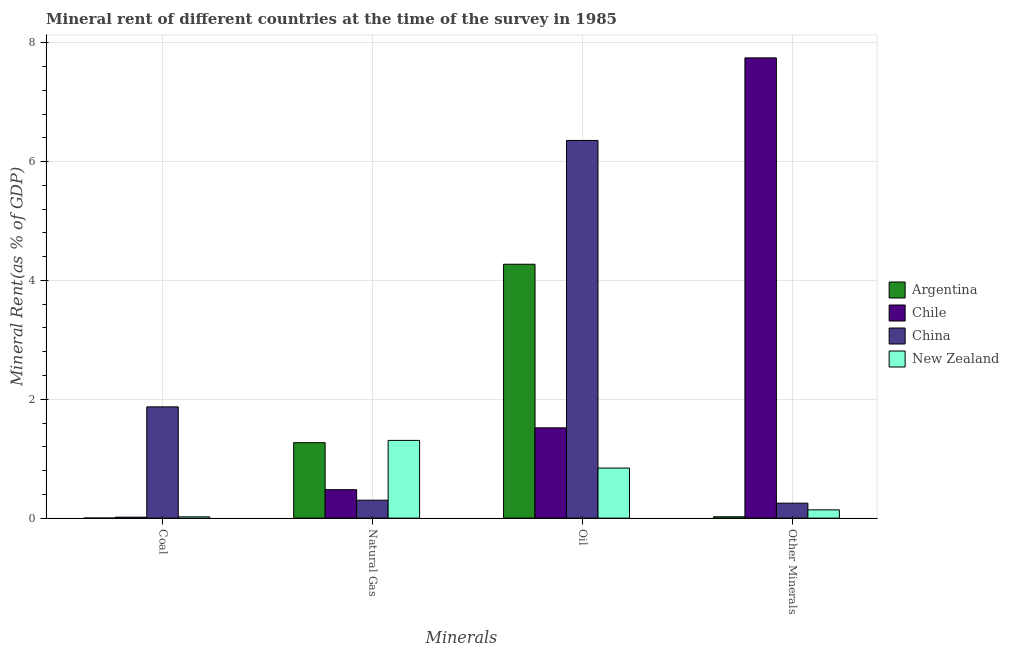How many different coloured bars are there?
Provide a succinct answer. 4. Are the number of bars per tick equal to the number of legend labels?
Ensure brevity in your answer.  Yes. How many bars are there on the 1st tick from the left?
Make the answer very short. 4. What is the label of the 4th group of bars from the left?
Ensure brevity in your answer.  Other Minerals. What is the  rent of other minerals in China?
Give a very brief answer. 0.25. Across all countries, what is the maximum coal rent?
Give a very brief answer. 1.87. Across all countries, what is the minimum oil rent?
Provide a succinct answer. 0.84. What is the total oil rent in the graph?
Offer a terse response. 12.99. What is the difference between the  rent of other minerals in China and that in Chile?
Provide a succinct answer. -7.49. What is the difference between the natural gas rent in New Zealand and the oil rent in Argentina?
Offer a terse response. -2.96. What is the average oil rent per country?
Your answer should be very brief. 3.25. What is the difference between the oil rent and  rent of other minerals in Argentina?
Keep it short and to the point. 4.25. In how many countries, is the oil rent greater than 2.8 %?
Ensure brevity in your answer.  2. What is the ratio of the oil rent in Chile to that in China?
Provide a succinct answer. 0.24. Is the difference between the oil rent in Chile and Argentina greater than the difference between the natural gas rent in Chile and Argentina?
Provide a succinct answer. No. What is the difference between the highest and the second highest oil rent?
Your answer should be compact. 2.08. What is the difference between the highest and the lowest coal rent?
Give a very brief answer. 1.87. In how many countries, is the  rent of other minerals greater than the average  rent of other minerals taken over all countries?
Offer a terse response. 1. Is it the case that in every country, the sum of the  rent of other minerals and coal rent is greater than the sum of natural gas rent and oil rent?
Your response must be concise. No. What does the 4th bar from the left in Oil represents?
Ensure brevity in your answer.  New Zealand. What does the 1st bar from the right in Coal represents?
Give a very brief answer. New Zealand. Is it the case that in every country, the sum of the coal rent and natural gas rent is greater than the oil rent?
Keep it short and to the point. No. How many countries are there in the graph?
Your response must be concise. 4. Does the graph contain grids?
Ensure brevity in your answer.  Yes. Where does the legend appear in the graph?
Offer a very short reply. Center right. What is the title of the graph?
Your answer should be very brief. Mineral rent of different countries at the time of the survey in 1985. Does "Mali" appear as one of the legend labels in the graph?
Ensure brevity in your answer.  No. What is the label or title of the X-axis?
Give a very brief answer. Minerals. What is the label or title of the Y-axis?
Ensure brevity in your answer.  Mineral Rent(as % of GDP). What is the Mineral Rent(as % of GDP) in Argentina in Coal?
Offer a very short reply. 0. What is the Mineral Rent(as % of GDP) in Chile in Coal?
Make the answer very short. 0.02. What is the Mineral Rent(as % of GDP) in China in Coal?
Your response must be concise. 1.87. What is the Mineral Rent(as % of GDP) of New Zealand in Coal?
Offer a very short reply. 0.02. What is the Mineral Rent(as % of GDP) in Argentina in Natural Gas?
Your response must be concise. 1.27. What is the Mineral Rent(as % of GDP) of Chile in Natural Gas?
Keep it short and to the point. 0.48. What is the Mineral Rent(as % of GDP) of China in Natural Gas?
Offer a terse response. 0.3. What is the Mineral Rent(as % of GDP) in New Zealand in Natural Gas?
Give a very brief answer. 1.31. What is the Mineral Rent(as % of GDP) in Argentina in Oil?
Your answer should be compact. 4.27. What is the Mineral Rent(as % of GDP) of Chile in Oil?
Give a very brief answer. 1.52. What is the Mineral Rent(as % of GDP) in China in Oil?
Your answer should be very brief. 6.36. What is the Mineral Rent(as % of GDP) in New Zealand in Oil?
Offer a terse response. 0.84. What is the Mineral Rent(as % of GDP) in Argentina in Other Minerals?
Your answer should be compact. 0.02. What is the Mineral Rent(as % of GDP) of Chile in Other Minerals?
Offer a very short reply. 7.75. What is the Mineral Rent(as % of GDP) of China in Other Minerals?
Provide a succinct answer. 0.25. What is the Mineral Rent(as % of GDP) in New Zealand in Other Minerals?
Keep it short and to the point. 0.14. Across all Minerals, what is the maximum Mineral Rent(as % of GDP) in Argentina?
Provide a short and direct response. 4.27. Across all Minerals, what is the maximum Mineral Rent(as % of GDP) in Chile?
Your response must be concise. 7.75. Across all Minerals, what is the maximum Mineral Rent(as % of GDP) of China?
Your response must be concise. 6.36. Across all Minerals, what is the maximum Mineral Rent(as % of GDP) in New Zealand?
Make the answer very short. 1.31. Across all Minerals, what is the minimum Mineral Rent(as % of GDP) in Argentina?
Make the answer very short. 0. Across all Minerals, what is the minimum Mineral Rent(as % of GDP) in Chile?
Provide a succinct answer. 0.02. Across all Minerals, what is the minimum Mineral Rent(as % of GDP) in China?
Give a very brief answer. 0.25. Across all Minerals, what is the minimum Mineral Rent(as % of GDP) of New Zealand?
Provide a short and direct response. 0.02. What is the total Mineral Rent(as % of GDP) in Argentina in the graph?
Your answer should be very brief. 5.57. What is the total Mineral Rent(as % of GDP) in Chile in the graph?
Keep it short and to the point. 9.76. What is the total Mineral Rent(as % of GDP) of China in the graph?
Offer a terse response. 8.78. What is the total Mineral Rent(as % of GDP) of New Zealand in the graph?
Provide a succinct answer. 2.31. What is the difference between the Mineral Rent(as % of GDP) in Argentina in Coal and that in Natural Gas?
Your response must be concise. -1.27. What is the difference between the Mineral Rent(as % of GDP) in Chile in Coal and that in Natural Gas?
Offer a very short reply. -0.46. What is the difference between the Mineral Rent(as % of GDP) of China in Coal and that in Natural Gas?
Provide a short and direct response. 1.57. What is the difference between the Mineral Rent(as % of GDP) in New Zealand in Coal and that in Natural Gas?
Provide a succinct answer. -1.29. What is the difference between the Mineral Rent(as % of GDP) in Argentina in Coal and that in Oil?
Offer a terse response. -4.27. What is the difference between the Mineral Rent(as % of GDP) in Chile in Coal and that in Oil?
Offer a very short reply. -1.5. What is the difference between the Mineral Rent(as % of GDP) of China in Coal and that in Oil?
Your response must be concise. -4.48. What is the difference between the Mineral Rent(as % of GDP) in New Zealand in Coal and that in Oil?
Give a very brief answer. -0.82. What is the difference between the Mineral Rent(as % of GDP) of Argentina in Coal and that in Other Minerals?
Ensure brevity in your answer.  -0.02. What is the difference between the Mineral Rent(as % of GDP) of Chile in Coal and that in Other Minerals?
Provide a succinct answer. -7.73. What is the difference between the Mineral Rent(as % of GDP) of China in Coal and that in Other Minerals?
Your answer should be very brief. 1.62. What is the difference between the Mineral Rent(as % of GDP) in New Zealand in Coal and that in Other Minerals?
Your answer should be compact. -0.12. What is the difference between the Mineral Rent(as % of GDP) in Argentina in Natural Gas and that in Oil?
Provide a succinct answer. -3. What is the difference between the Mineral Rent(as % of GDP) of Chile in Natural Gas and that in Oil?
Provide a short and direct response. -1.04. What is the difference between the Mineral Rent(as % of GDP) of China in Natural Gas and that in Oil?
Keep it short and to the point. -6.05. What is the difference between the Mineral Rent(as % of GDP) of New Zealand in Natural Gas and that in Oil?
Offer a very short reply. 0.47. What is the difference between the Mineral Rent(as % of GDP) in Argentina in Natural Gas and that in Other Minerals?
Your response must be concise. 1.25. What is the difference between the Mineral Rent(as % of GDP) in Chile in Natural Gas and that in Other Minerals?
Provide a succinct answer. -7.27. What is the difference between the Mineral Rent(as % of GDP) in China in Natural Gas and that in Other Minerals?
Your answer should be compact. 0.05. What is the difference between the Mineral Rent(as % of GDP) in New Zealand in Natural Gas and that in Other Minerals?
Your answer should be compact. 1.17. What is the difference between the Mineral Rent(as % of GDP) in Argentina in Oil and that in Other Minerals?
Offer a terse response. 4.25. What is the difference between the Mineral Rent(as % of GDP) of Chile in Oil and that in Other Minerals?
Provide a short and direct response. -6.23. What is the difference between the Mineral Rent(as % of GDP) in China in Oil and that in Other Minerals?
Keep it short and to the point. 6.1. What is the difference between the Mineral Rent(as % of GDP) of New Zealand in Oil and that in Other Minerals?
Make the answer very short. 0.7. What is the difference between the Mineral Rent(as % of GDP) of Argentina in Coal and the Mineral Rent(as % of GDP) of Chile in Natural Gas?
Provide a short and direct response. -0.48. What is the difference between the Mineral Rent(as % of GDP) in Argentina in Coal and the Mineral Rent(as % of GDP) in China in Natural Gas?
Your answer should be very brief. -0.3. What is the difference between the Mineral Rent(as % of GDP) in Argentina in Coal and the Mineral Rent(as % of GDP) in New Zealand in Natural Gas?
Your answer should be compact. -1.31. What is the difference between the Mineral Rent(as % of GDP) of Chile in Coal and the Mineral Rent(as % of GDP) of China in Natural Gas?
Keep it short and to the point. -0.29. What is the difference between the Mineral Rent(as % of GDP) of Chile in Coal and the Mineral Rent(as % of GDP) of New Zealand in Natural Gas?
Keep it short and to the point. -1.29. What is the difference between the Mineral Rent(as % of GDP) of China in Coal and the Mineral Rent(as % of GDP) of New Zealand in Natural Gas?
Provide a short and direct response. 0.56. What is the difference between the Mineral Rent(as % of GDP) in Argentina in Coal and the Mineral Rent(as % of GDP) in Chile in Oil?
Your answer should be compact. -1.52. What is the difference between the Mineral Rent(as % of GDP) of Argentina in Coal and the Mineral Rent(as % of GDP) of China in Oil?
Offer a very short reply. -6.36. What is the difference between the Mineral Rent(as % of GDP) of Argentina in Coal and the Mineral Rent(as % of GDP) of New Zealand in Oil?
Provide a succinct answer. -0.84. What is the difference between the Mineral Rent(as % of GDP) of Chile in Coal and the Mineral Rent(as % of GDP) of China in Oil?
Provide a short and direct response. -6.34. What is the difference between the Mineral Rent(as % of GDP) of Chile in Coal and the Mineral Rent(as % of GDP) of New Zealand in Oil?
Your answer should be compact. -0.83. What is the difference between the Mineral Rent(as % of GDP) in China in Coal and the Mineral Rent(as % of GDP) in New Zealand in Oil?
Keep it short and to the point. 1.03. What is the difference between the Mineral Rent(as % of GDP) in Argentina in Coal and the Mineral Rent(as % of GDP) in Chile in Other Minerals?
Your response must be concise. -7.75. What is the difference between the Mineral Rent(as % of GDP) in Argentina in Coal and the Mineral Rent(as % of GDP) in China in Other Minerals?
Keep it short and to the point. -0.25. What is the difference between the Mineral Rent(as % of GDP) in Argentina in Coal and the Mineral Rent(as % of GDP) in New Zealand in Other Minerals?
Keep it short and to the point. -0.14. What is the difference between the Mineral Rent(as % of GDP) in Chile in Coal and the Mineral Rent(as % of GDP) in China in Other Minerals?
Make the answer very short. -0.24. What is the difference between the Mineral Rent(as % of GDP) of Chile in Coal and the Mineral Rent(as % of GDP) of New Zealand in Other Minerals?
Provide a succinct answer. -0.12. What is the difference between the Mineral Rent(as % of GDP) of China in Coal and the Mineral Rent(as % of GDP) of New Zealand in Other Minerals?
Give a very brief answer. 1.73. What is the difference between the Mineral Rent(as % of GDP) of Argentina in Natural Gas and the Mineral Rent(as % of GDP) of Chile in Oil?
Your response must be concise. -0.25. What is the difference between the Mineral Rent(as % of GDP) of Argentina in Natural Gas and the Mineral Rent(as % of GDP) of China in Oil?
Your answer should be compact. -5.09. What is the difference between the Mineral Rent(as % of GDP) in Argentina in Natural Gas and the Mineral Rent(as % of GDP) in New Zealand in Oil?
Your answer should be compact. 0.43. What is the difference between the Mineral Rent(as % of GDP) in Chile in Natural Gas and the Mineral Rent(as % of GDP) in China in Oil?
Your answer should be compact. -5.88. What is the difference between the Mineral Rent(as % of GDP) of Chile in Natural Gas and the Mineral Rent(as % of GDP) of New Zealand in Oil?
Give a very brief answer. -0.36. What is the difference between the Mineral Rent(as % of GDP) in China in Natural Gas and the Mineral Rent(as % of GDP) in New Zealand in Oil?
Keep it short and to the point. -0.54. What is the difference between the Mineral Rent(as % of GDP) in Argentina in Natural Gas and the Mineral Rent(as % of GDP) in Chile in Other Minerals?
Your answer should be compact. -6.48. What is the difference between the Mineral Rent(as % of GDP) of Argentina in Natural Gas and the Mineral Rent(as % of GDP) of China in Other Minerals?
Offer a very short reply. 1.02. What is the difference between the Mineral Rent(as % of GDP) of Argentina in Natural Gas and the Mineral Rent(as % of GDP) of New Zealand in Other Minerals?
Provide a succinct answer. 1.13. What is the difference between the Mineral Rent(as % of GDP) in Chile in Natural Gas and the Mineral Rent(as % of GDP) in China in Other Minerals?
Offer a very short reply. 0.23. What is the difference between the Mineral Rent(as % of GDP) in Chile in Natural Gas and the Mineral Rent(as % of GDP) in New Zealand in Other Minerals?
Offer a terse response. 0.34. What is the difference between the Mineral Rent(as % of GDP) in China in Natural Gas and the Mineral Rent(as % of GDP) in New Zealand in Other Minerals?
Offer a very short reply. 0.16. What is the difference between the Mineral Rent(as % of GDP) in Argentina in Oil and the Mineral Rent(as % of GDP) in Chile in Other Minerals?
Keep it short and to the point. -3.47. What is the difference between the Mineral Rent(as % of GDP) in Argentina in Oil and the Mineral Rent(as % of GDP) in China in Other Minerals?
Ensure brevity in your answer.  4.02. What is the difference between the Mineral Rent(as % of GDP) of Argentina in Oil and the Mineral Rent(as % of GDP) of New Zealand in Other Minerals?
Provide a succinct answer. 4.13. What is the difference between the Mineral Rent(as % of GDP) of Chile in Oil and the Mineral Rent(as % of GDP) of China in Other Minerals?
Provide a short and direct response. 1.27. What is the difference between the Mineral Rent(as % of GDP) of Chile in Oil and the Mineral Rent(as % of GDP) of New Zealand in Other Minerals?
Give a very brief answer. 1.38. What is the difference between the Mineral Rent(as % of GDP) in China in Oil and the Mineral Rent(as % of GDP) in New Zealand in Other Minerals?
Give a very brief answer. 6.22. What is the average Mineral Rent(as % of GDP) of Argentina per Minerals?
Ensure brevity in your answer.  1.39. What is the average Mineral Rent(as % of GDP) of Chile per Minerals?
Offer a terse response. 2.44. What is the average Mineral Rent(as % of GDP) of China per Minerals?
Keep it short and to the point. 2.2. What is the average Mineral Rent(as % of GDP) in New Zealand per Minerals?
Give a very brief answer. 0.58. What is the difference between the Mineral Rent(as % of GDP) in Argentina and Mineral Rent(as % of GDP) in Chile in Coal?
Keep it short and to the point. -0.02. What is the difference between the Mineral Rent(as % of GDP) of Argentina and Mineral Rent(as % of GDP) of China in Coal?
Your response must be concise. -1.87. What is the difference between the Mineral Rent(as % of GDP) of Argentina and Mineral Rent(as % of GDP) of New Zealand in Coal?
Your answer should be compact. -0.02. What is the difference between the Mineral Rent(as % of GDP) in Chile and Mineral Rent(as % of GDP) in China in Coal?
Provide a succinct answer. -1.86. What is the difference between the Mineral Rent(as % of GDP) in Chile and Mineral Rent(as % of GDP) in New Zealand in Coal?
Provide a succinct answer. -0.01. What is the difference between the Mineral Rent(as % of GDP) in China and Mineral Rent(as % of GDP) in New Zealand in Coal?
Offer a very short reply. 1.85. What is the difference between the Mineral Rent(as % of GDP) in Argentina and Mineral Rent(as % of GDP) in Chile in Natural Gas?
Your response must be concise. 0.79. What is the difference between the Mineral Rent(as % of GDP) in Argentina and Mineral Rent(as % of GDP) in China in Natural Gas?
Your answer should be compact. 0.97. What is the difference between the Mineral Rent(as % of GDP) of Argentina and Mineral Rent(as % of GDP) of New Zealand in Natural Gas?
Your answer should be compact. -0.04. What is the difference between the Mineral Rent(as % of GDP) in Chile and Mineral Rent(as % of GDP) in China in Natural Gas?
Offer a very short reply. 0.18. What is the difference between the Mineral Rent(as % of GDP) of Chile and Mineral Rent(as % of GDP) of New Zealand in Natural Gas?
Offer a terse response. -0.83. What is the difference between the Mineral Rent(as % of GDP) in China and Mineral Rent(as % of GDP) in New Zealand in Natural Gas?
Your answer should be very brief. -1.01. What is the difference between the Mineral Rent(as % of GDP) of Argentina and Mineral Rent(as % of GDP) of Chile in Oil?
Ensure brevity in your answer.  2.75. What is the difference between the Mineral Rent(as % of GDP) of Argentina and Mineral Rent(as % of GDP) of China in Oil?
Provide a short and direct response. -2.08. What is the difference between the Mineral Rent(as % of GDP) of Argentina and Mineral Rent(as % of GDP) of New Zealand in Oil?
Offer a terse response. 3.43. What is the difference between the Mineral Rent(as % of GDP) of Chile and Mineral Rent(as % of GDP) of China in Oil?
Provide a succinct answer. -4.84. What is the difference between the Mineral Rent(as % of GDP) in Chile and Mineral Rent(as % of GDP) in New Zealand in Oil?
Provide a short and direct response. 0.68. What is the difference between the Mineral Rent(as % of GDP) in China and Mineral Rent(as % of GDP) in New Zealand in Oil?
Provide a succinct answer. 5.51. What is the difference between the Mineral Rent(as % of GDP) in Argentina and Mineral Rent(as % of GDP) in Chile in Other Minerals?
Provide a short and direct response. -7.72. What is the difference between the Mineral Rent(as % of GDP) in Argentina and Mineral Rent(as % of GDP) in China in Other Minerals?
Offer a terse response. -0.23. What is the difference between the Mineral Rent(as % of GDP) in Argentina and Mineral Rent(as % of GDP) in New Zealand in Other Minerals?
Make the answer very short. -0.12. What is the difference between the Mineral Rent(as % of GDP) of Chile and Mineral Rent(as % of GDP) of China in Other Minerals?
Offer a very short reply. 7.49. What is the difference between the Mineral Rent(as % of GDP) of Chile and Mineral Rent(as % of GDP) of New Zealand in Other Minerals?
Provide a succinct answer. 7.61. What is the difference between the Mineral Rent(as % of GDP) in China and Mineral Rent(as % of GDP) in New Zealand in Other Minerals?
Your response must be concise. 0.11. What is the ratio of the Mineral Rent(as % of GDP) in Argentina in Coal to that in Natural Gas?
Make the answer very short. 0. What is the ratio of the Mineral Rent(as % of GDP) of China in Coal to that in Natural Gas?
Offer a terse response. 6.21. What is the ratio of the Mineral Rent(as % of GDP) of New Zealand in Coal to that in Natural Gas?
Your response must be concise. 0.02. What is the ratio of the Mineral Rent(as % of GDP) in Argentina in Coal to that in Oil?
Ensure brevity in your answer.  0. What is the ratio of the Mineral Rent(as % of GDP) in Chile in Coal to that in Oil?
Offer a terse response. 0.01. What is the ratio of the Mineral Rent(as % of GDP) in China in Coal to that in Oil?
Your answer should be very brief. 0.29. What is the ratio of the Mineral Rent(as % of GDP) in New Zealand in Coal to that in Oil?
Give a very brief answer. 0.03. What is the ratio of the Mineral Rent(as % of GDP) in Argentina in Coal to that in Other Minerals?
Offer a very short reply. 0.03. What is the ratio of the Mineral Rent(as % of GDP) in Chile in Coal to that in Other Minerals?
Provide a short and direct response. 0. What is the ratio of the Mineral Rent(as % of GDP) of China in Coal to that in Other Minerals?
Your answer should be very brief. 7.44. What is the ratio of the Mineral Rent(as % of GDP) of New Zealand in Coal to that in Other Minerals?
Provide a succinct answer. 0.16. What is the ratio of the Mineral Rent(as % of GDP) in Argentina in Natural Gas to that in Oil?
Your answer should be compact. 0.3. What is the ratio of the Mineral Rent(as % of GDP) of Chile in Natural Gas to that in Oil?
Give a very brief answer. 0.31. What is the ratio of the Mineral Rent(as % of GDP) of China in Natural Gas to that in Oil?
Make the answer very short. 0.05. What is the ratio of the Mineral Rent(as % of GDP) of New Zealand in Natural Gas to that in Oil?
Your answer should be compact. 1.55. What is the ratio of the Mineral Rent(as % of GDP) in Argentina in Natural Gas to that in Other Minerals?
Provide a short and direct response. 56.2. What is the ratio of the Mineral Rent(as % of GDP) of Chile in Natural Gas to that in Other Minerals?
Ensure brevity in your answer.  0.06. What is the ratio of the Mineral Rent(as % of GDP) in China in Natural Gas to that in Other Minerals?
Keep it short and to the point. 1.2. What is the ratio of the Mineral Rent(as % of GDP) in New Zealand in Natural Gas to that in Other Minerals?
Make the answer very short. 9.4. What is the ratio of the Mineral Rent(as % of GDP) in Argentina in Oil to that in Other Minerals?
Provide a short and direct response. 189.12. What is the ratio of the Mineral Rent(as % of GDP) in Chile in Oil to that in Other Minerals?
Your answer should be compact. 0.2. What is the ratio of the Mineral Rent(as % of GDP) of China in Oil to that in Other Minerals?
Provide a succinct answer. 25.26. What is the ratio of the Mineral Rent(as % of GDP) of New Zealand in Oil to that in Other Minerals?
Keep it short and to the point. 6.05. What is the difference between the highest and the second highest Mineral Rent(as % of GDP) in Argentina?
Offer a very short reply. 3. What is the difference between the highest and the second highest Mineral Rent(as % of GDP) in Chile?
Your answer should be very brief. 6.23. What is the difference between the highest and the second highest Mineral Rent(as % of GDP) in China?
Provide a short and direct response. 4.48. What is the difference between the highest and the second highest Mineral Rent(as % of GDP) in New Zealand?
Make the answer very short. 0.47. What is the difference between the highest and the lowest Mineral Rent(as % of GDP) of Argentina?
Provide a short and direct response. 4.27. What is the difference between the highest and the lowest Mineral Rent(as % of GDP) in Chile?
Offer a very short reply. 7.73. What is the difference between the highest and the lowest Mineral Rent(as % of GDP) in China?
Your response must be concise. 6.1. What is the difference between the highest and the lowest Mineral Rent(as % of GDP) in New Zealand?
Your answer should be compact. 1.29. 